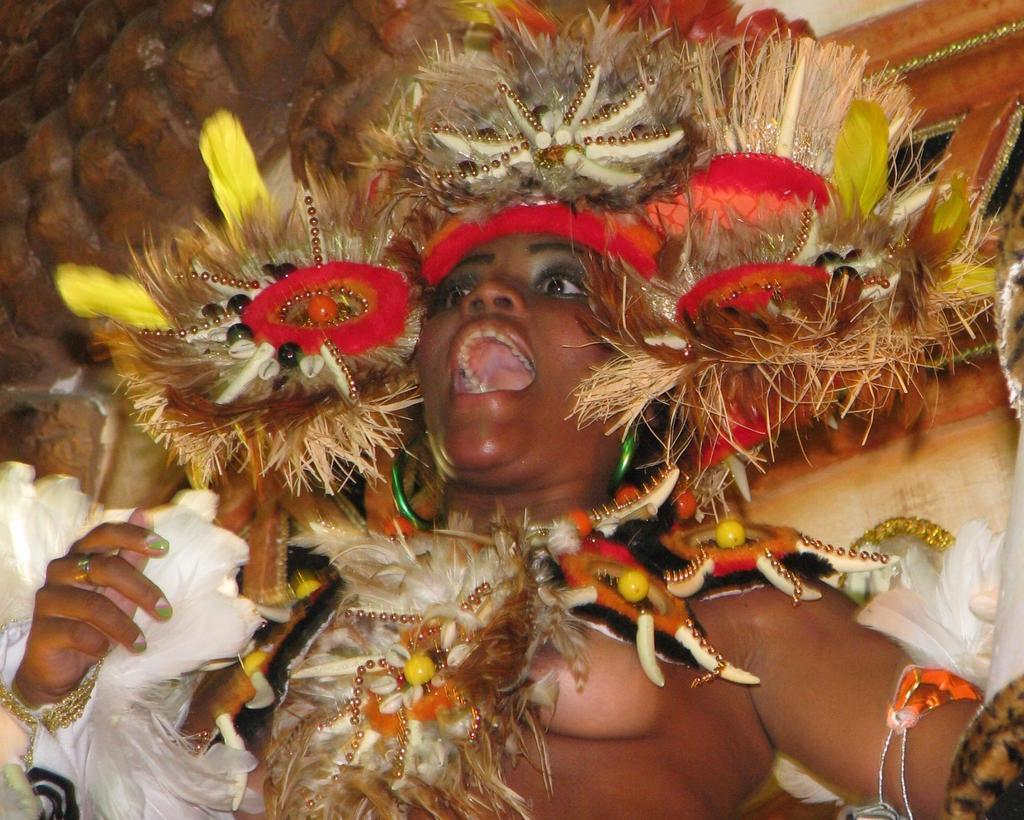What is the main subject of the image? The main subject of the image is a woman. What is the woman wearing in the image? The woman is wearing a costume in the image. Can you tell me how many sheep are present in the image? There are no sheep present in the image; it features a woman wearing a costume. What type of kitty can be seen interacting with the woman in the image? There is no kitty present in the image; the woman is the only subject visible. 